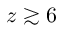Convert formula to latex. <formula><loc_0><loc_0><loc_500><loc_500>z \gtrsim 6</formula> 